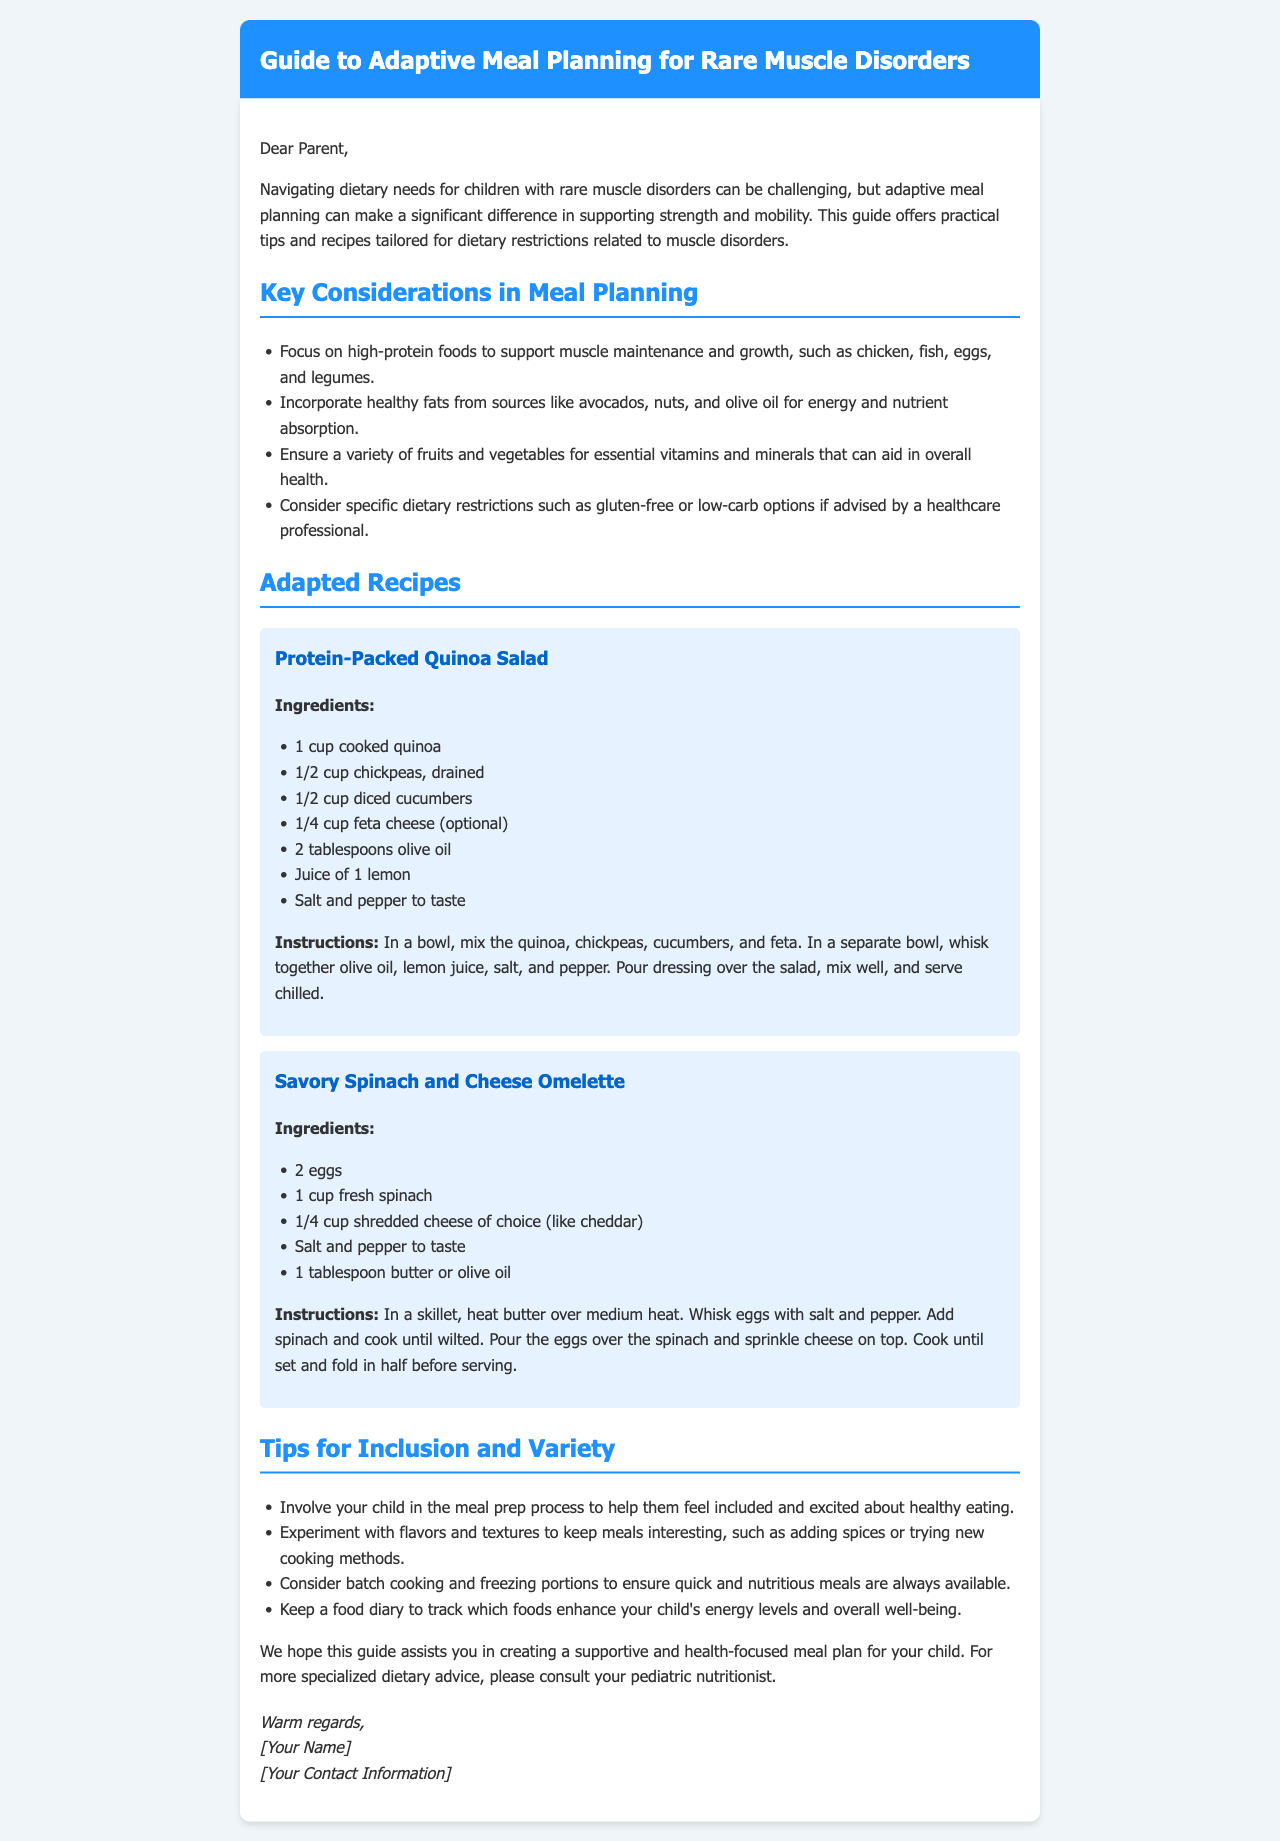What is the title of the document? The title is the main heading of the document displayed prominently at the top.
Answer: Guide to Adaptive Meal Planning for Rare Muscle Disorders What type of food should be focused on for muscle maintenance? This information can be found in the "Key Considerations in Meal Planning" section regarding high-protein foods.
Answer: High-protein foods Which recipe includes chickpeas? The recipe section contains two recipes, and this recipe specifically mentions chickpeas as an ingredient.
Answer: Protein-Packed Quinoa Salad What is a suggested oil for cooking in the omelette recipe? The ingredients listed for the omelette specify what type of oil can be used.
Answer: Olive oil How many eggs are required for the Savory Spinach and Cheese Omelette? This is a specific detail from the ingredients list for the omelette recipe.
Answer: 2 eggs What is one method suggested for meal variety? The document provides tips to enhance meal preparation and variety.
Answer: Experiment with flavors and textures Which greens are used in the Savory Spinach and Cheese Omelette? This detail can be found in the list of ingredients for the omelette recipe.
Answer: Fresh spinach Who should you consult for specialized dietary advice? The document advises consulting a professional regarding dietary needs.
Answer: Pediatric nutritionist 